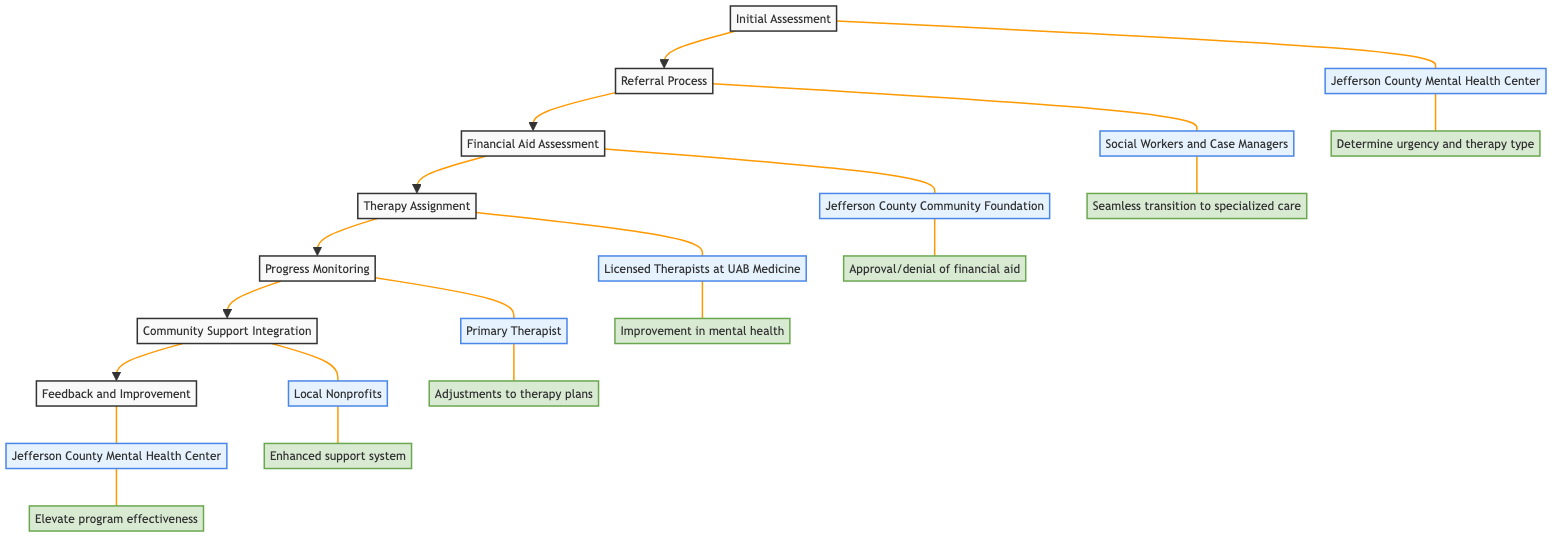What is the first step in the clinical pathway? The diagram shows "Initial Assessment" as the first step that leads to others in the pathway.
Answer: Initial Assessment Who conducts the initial assessment? The entity responsible for the initial assessment in the diagram is "Jefferson County Mental Health Center".
Answer: Jefferson County Mental Health Center What is the outcome of the referral process? The outcome of the referral process as indicated in the diagram is "Seamless transition to specialized care".
Answer: Seamless transition to specialized care Which entity evaluates financial eligibility for aid? Based on the diagram, the "Jefferson County Community Foundation" is responsible for evaluating financial eligibility for aid.
Answer: Jefferson County Community Foundation How many steps are there in total in the clinical pathway? Counting the steps outlined in the diagram, there are a total of 7 steps in the clinical pathway.
Answer: 7 What follows the financial aid assessment in the pathway? After the financial aid assessment, the next step in the pathway is the "Therapy Assignment".
Answer: Therapy Assignment What type of therapy is assigned by the licensed therapists? According to the diagram, the licensed therapists assign therapy sessions, which can include various types such as "Cognitive Behavioral Therapy" and "Group Therapy."
Answer: Cognitive Behavioral Therapy, Group Therapy Who is responsible for progress monitoring? The diagram identifies the "Primary Therapist" as the responsible entity for progress monitoring.
Answer: Primary Therapist What is the final step in the clinical pathway? The last step in the clinical pathway, as illustrated in the diagram, is "Feedback and Improvement".
Answer: Feedback and Improvement 